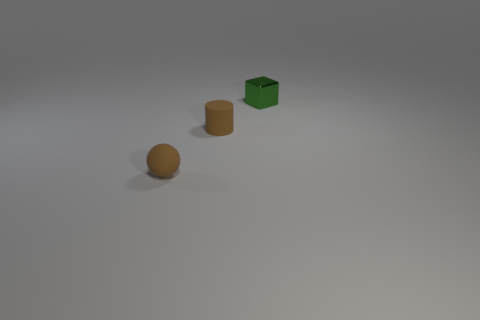What materials do these objects seem to be made of? The objects in the image appear to have a matte finish, suggesting that they are possibly made of a non-reflective plastic or a similarly textured material. 